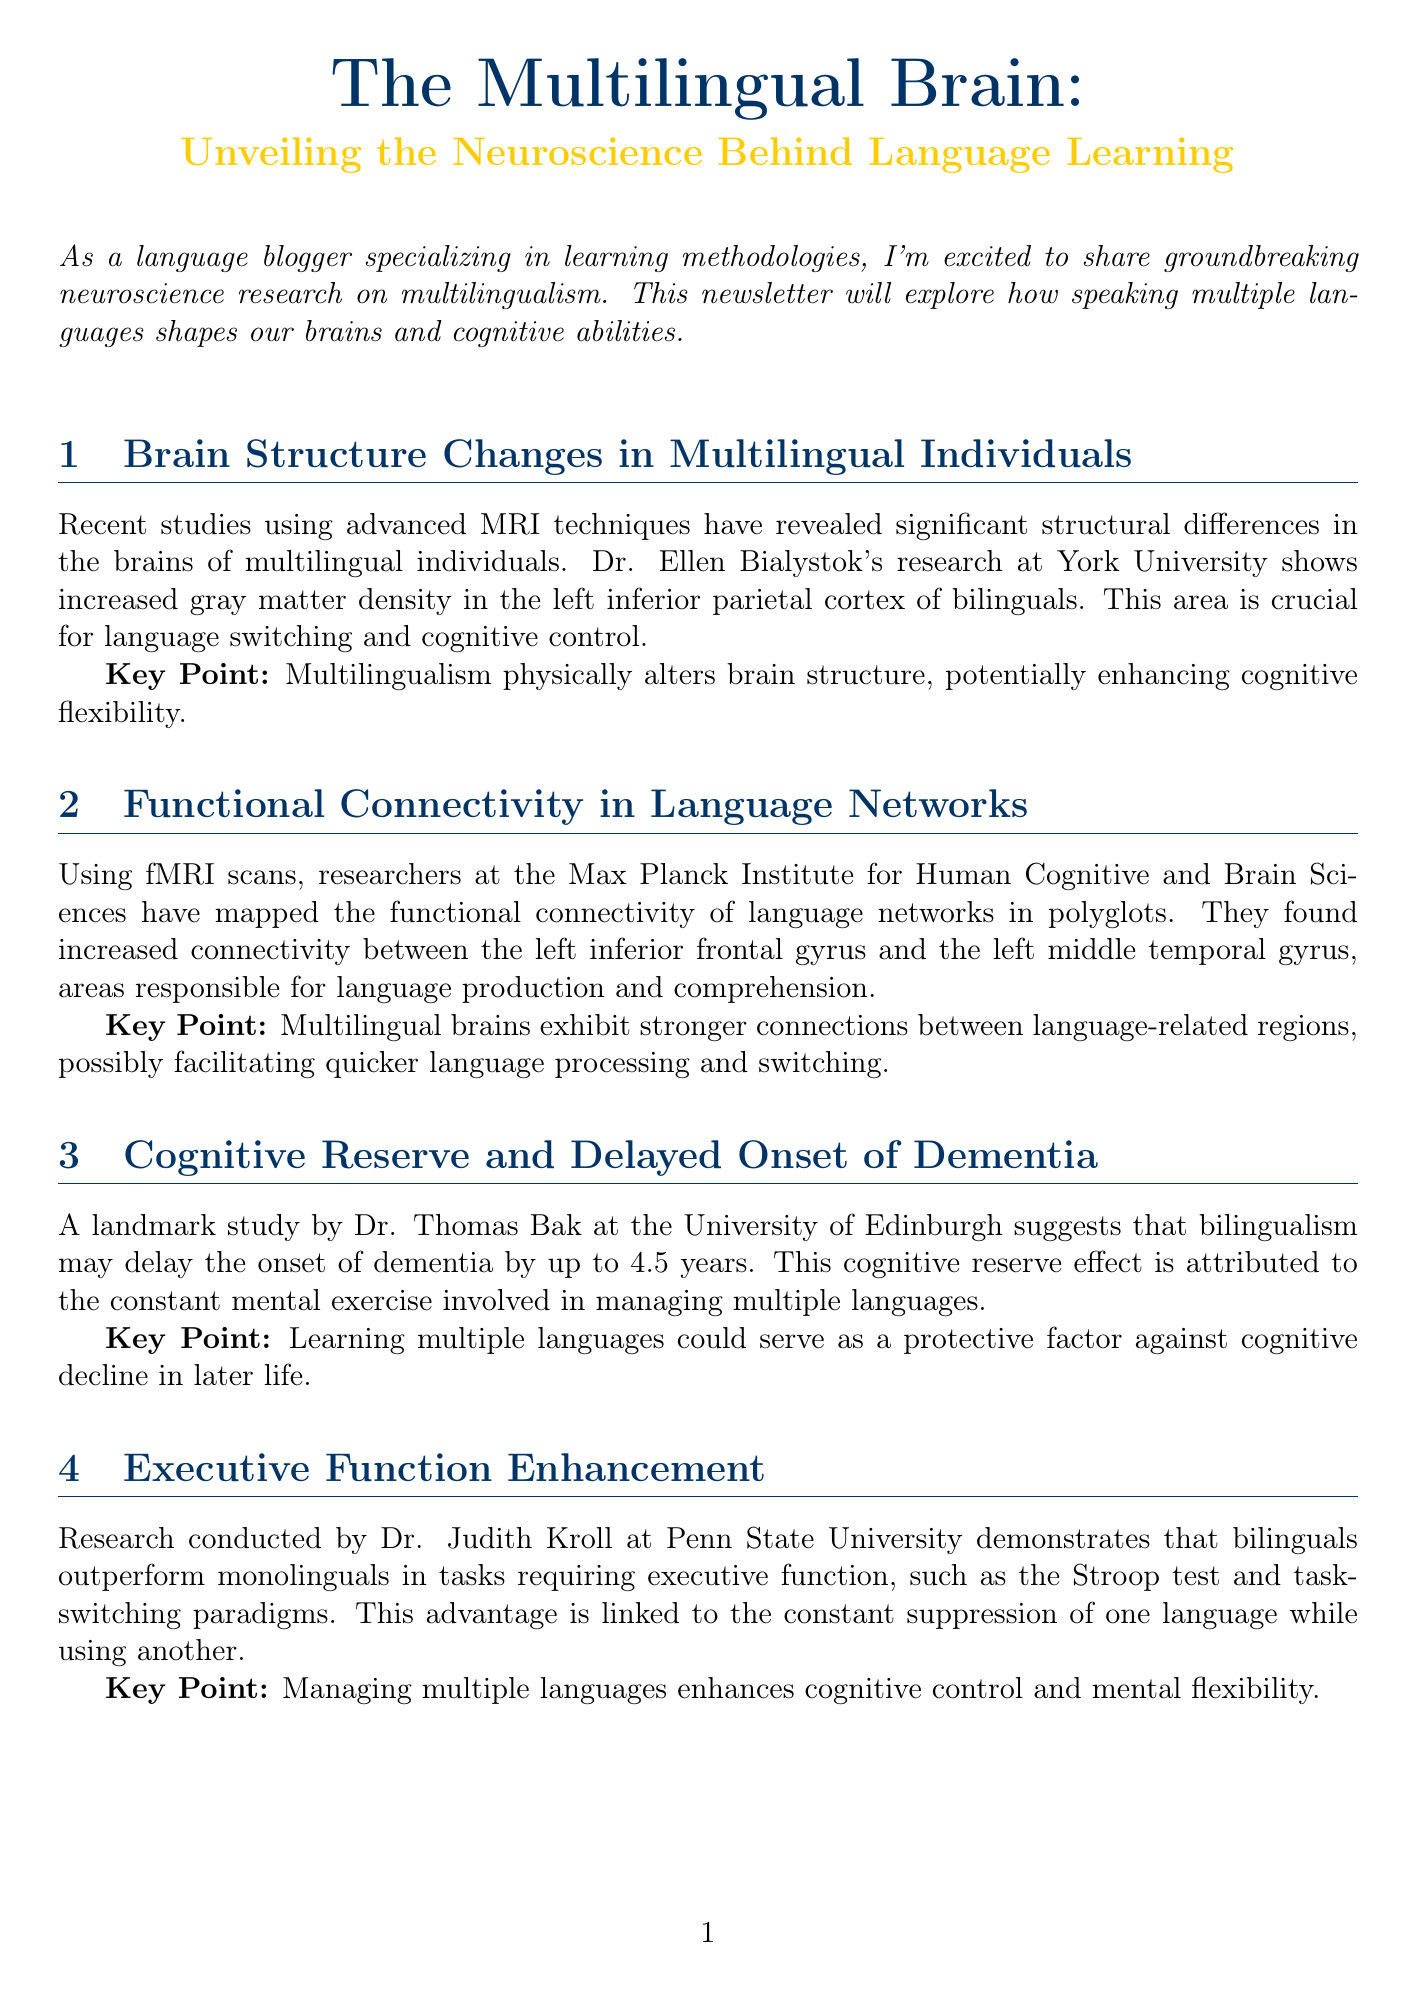What is the title of the newsletter? The title of the newsletter is presented prominently at the beginning of the document.
Answer: The Multilingual Brain: Unveiling the Neuroscience Behind Language Learning Who conducted research on brain structure changes in multilingual individuals? The document provides the name of the researcher who studied brain structure changes related to multilingualism.
Answer: Dr. Ellen Bialystok Which brain area shows increased gray matter density in bilinguals? The specific brain area that has been identified in bilinguals through MRI techniques is mentioned in the document.
Answer: Left inferior parietal cortex What cognitive advantage do bilinguals have in executive function tasks? The document states the benefit bilinguals exhibit over monolinguals in tasks requiring executive function.
Answer: Outperform How many years can bilingualism delay the onset of dementia according to Dr. Thomas Bak's study? The document cites a specific figure indicating how much bilingualism can delay dementia onset.
Answer: 4.5 years What practical implication involves children? The document discusses a practical approach related to children in the context of language learning.
Answer: Encouraging early second language acquisition Who is the expert interviewed in the newsletter? The name and title of the expert featured in the interview section of the newsletter are provided.
Answer: Dr. Arturo Hernandez What method is suggested to enhance cognitive control in language learning? The document lists a specific exercise related to language management that may improve cognitive control.
Answer: Language switching exercises 